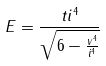Convert formula to latex. <formula><loc_0><loc_0><loc_500><loc_500>E = \frac { t i ^ { 4 } } { \sqrt { 6 - \frac { v ^ { 4 } } { i ^ { 4 } } } }</formula> 